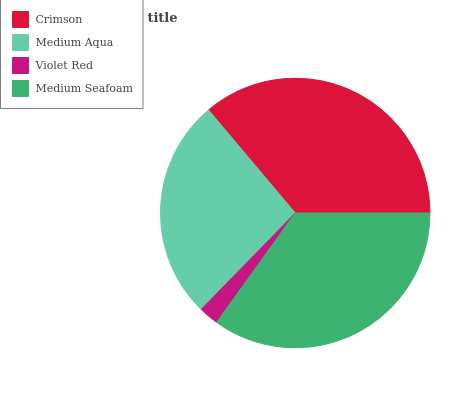Is Violet Red the minimum?
Answer yes or no. Yes. Is Crimson the maximum?
Answer yes or no. Yes. Is Medium Aqua the minimum?
Answer yes or no. No. Is Medium Aqua the maximum?
Answer yes or no. No. Is Crimson greater than Medium Aqua?
Answer yes or no. Yes. Is Medium Aqua less than Crimson?
Answer yes or no. Yes. Is Medium Aqua greater than Crimson?
Answer yes or no. No. Is Crimson less than Medium Aqua?
Answer yes or no. No. Is Medium Seafoam the high median?
Answer yes or no. Yes. Is Medium Aqua the low median?
Answer yes or no. Yes. Is Crimson the high median?
Answer yes or no. No. Is Violet Red the low median?
Answer yes or no. No. 